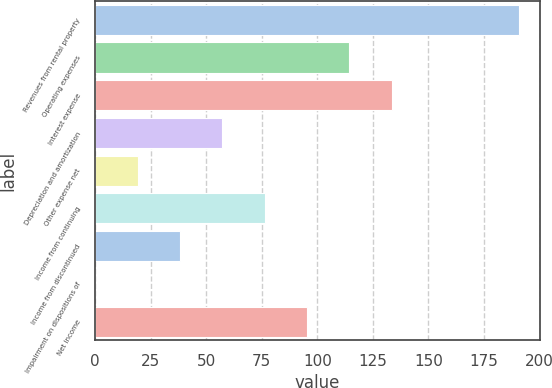<chart> <loc_0><loc_0><loc_500><loc_500><bar_chart><fcel>Revenues from rental property<fcel>Operating expenses<fcel>Interest expense<fcel>Depreciation and amortization<fcel>Other expense net<fcel>Income from continuing<fcel>Income from discontinued<fcel>Impairment on dispositions of<fcel>Net income<nl><fcel>190.6<fcel>114.4<fcel>133.45<fcel>57.25<fcel>19.15<fcel>76.3<fcel>38.2<fcel>0.1<fcel>95.35<nl></chart> 